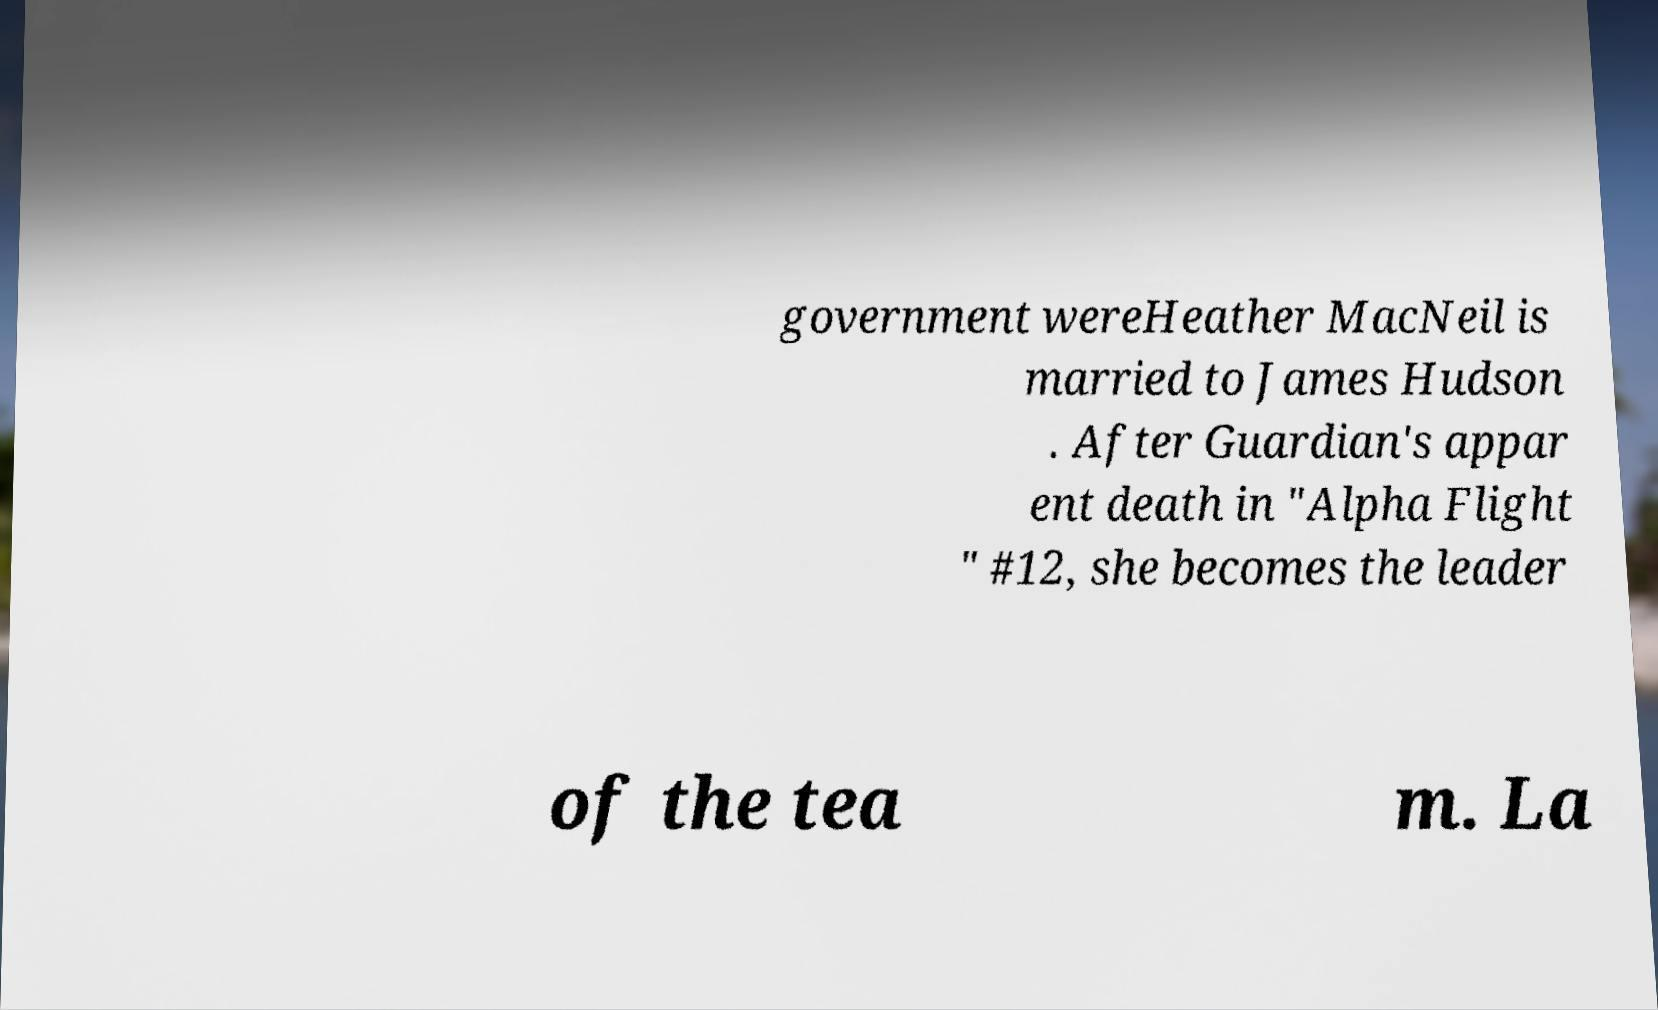Can you read and provide the text displayed in the image?This photo seems to have some interesting text. Can you extract and type it out for me? government wereHeather MacNeil is married to James Hudson . After Guardian's appar ent death in "Alpha Flight " #12, she becomes the leader of the tea m. La 